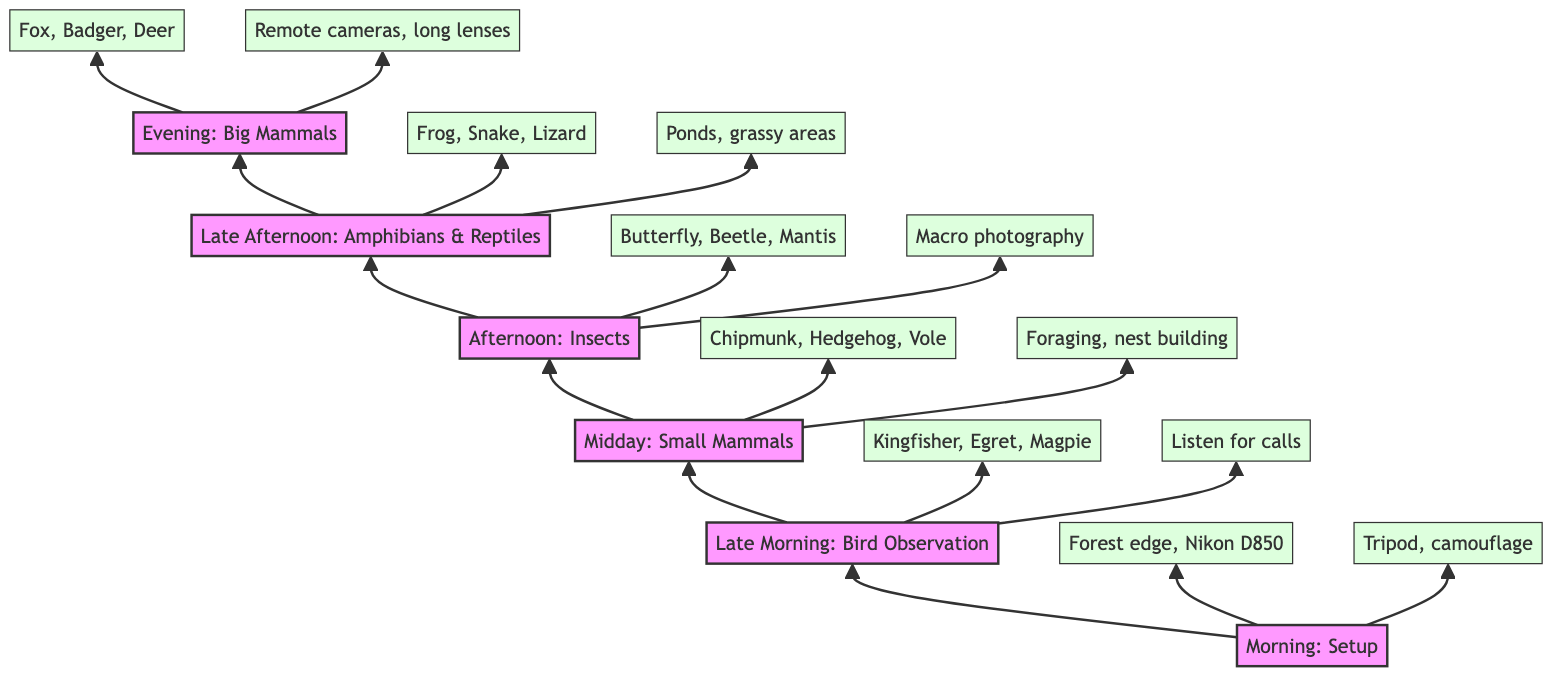What is the first activity listed in the diagram? The first activity at the bottom of the flow chart is "Setup," which occurs in the morning. This can be found by directly looking at the first node at the bottom of the diagram and identifying its label.
Answer: Setup How many key species are observed during the Late Morning? In the Late Morning observation, three key species are listed: Common Kingfisher, Great Egret, and Red-billed Blue Magpie. By counting the items under key species in the Late Morning node, we find three species.
Answer: 3 What equipment is specified for the morning setup? The details for the morning setup mention "Nikon D850 with 500mm lens." This is explicitly stated under the morning activity node, which specifies the camera equipment used.
Answer: Nikon D850 with 500mm lens What type of photography technique is used during insect documentation? The activity during the Afternoon for insect documentation states the technique used is "Macro photography." This is found directly under the Afternoon activity node and indicates the method of capturing details of insects.
Answer: Macro photography Which time period involves observing amphibians and reptiles? The Late Afternoon time period is explicitly labeled for the observation of amphibians and reptiles. It can be seen by locating the Late Afternoon node in the flow chart, which indicates the specific activity for that time.
Answer: Late Afternoon Explain the challenges faced during the observation of small mammals. The observation of small mammals has the challenge of needing to "Stay downwind to avoid detection." This requires reasoning by looking at the Midday node and examining the details for that specific activity. This challenge explains the strategy that must be employed.
Answer: Stay downwind to avoid detection What are the two key species of big mammals listed? The key species of big mammals listed are "Red Fox" and "European Badger." By checking the Evening node, we can see the key species mentioned under that activity, where there are also additional species included.
Answer: Red Fox, European Badger In what time frame is macro photography emphasized? Macro photography is emphasized in the "Afternoon" time frame, as stated in the details of the Afternoon activity node. By reading through the nodes, one can notice which specific activity highlights macro photography.
Answer: Afternoon What challenges are presented for evening observations of mammals? The challenge for evening observations of mammals is "Low light conditions." This is stated in the details under the Evening activity, indicating the difficulties presented when observing mammals during that time.
Answer: Low light conditions 